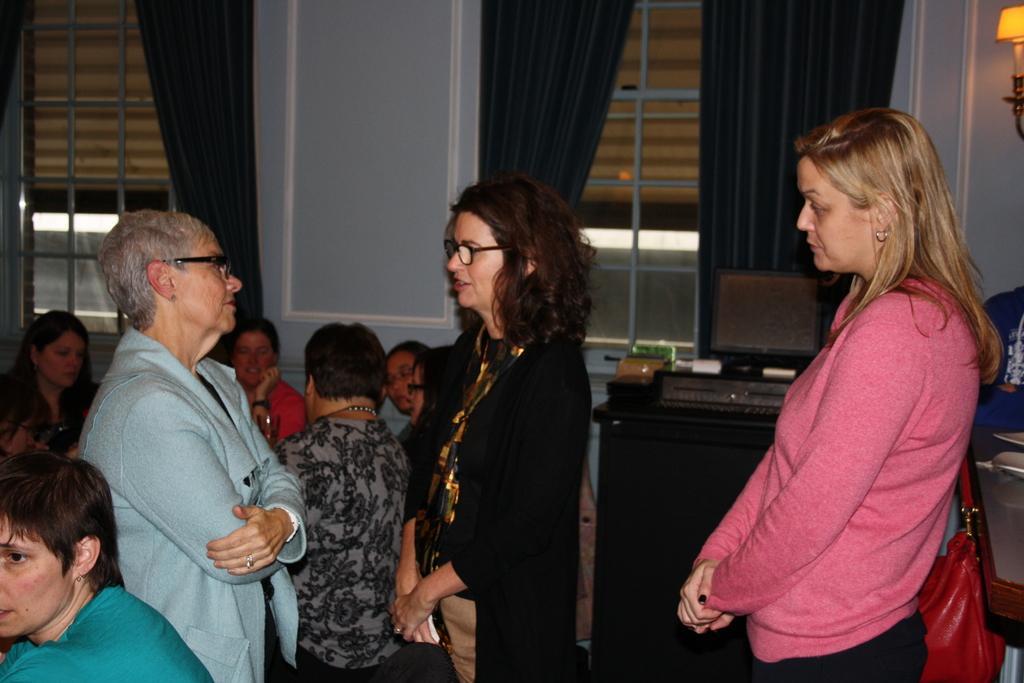Could you give a brief overview of what you see in this image? In this image, we can see some people standing and there are some windows and we can see the curtains. 